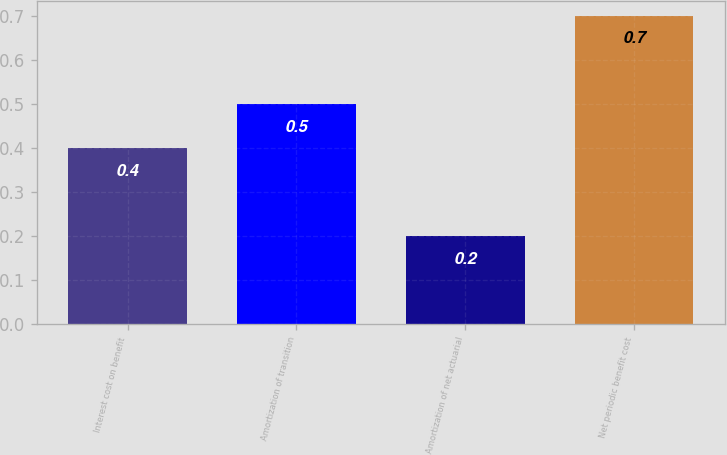Convert chart. <chart><loc_0><loc_0><loc_500><loc_500><bar_chart><fcel>Interest cost on benefit<fcel>Amortization of transition<fcel>Amortization of net actuarial<fcel>Net periodic benefit cost<nl><fcel>0.4<fcel>0.5<fcel>0.2<fcel>0.7<nl></chart> 